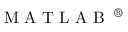Convert formula to latex. <formula><loc_0><loc_0><loc_500><loc_500>M A T L A B \text  superscript { \text  registered }</formula> 